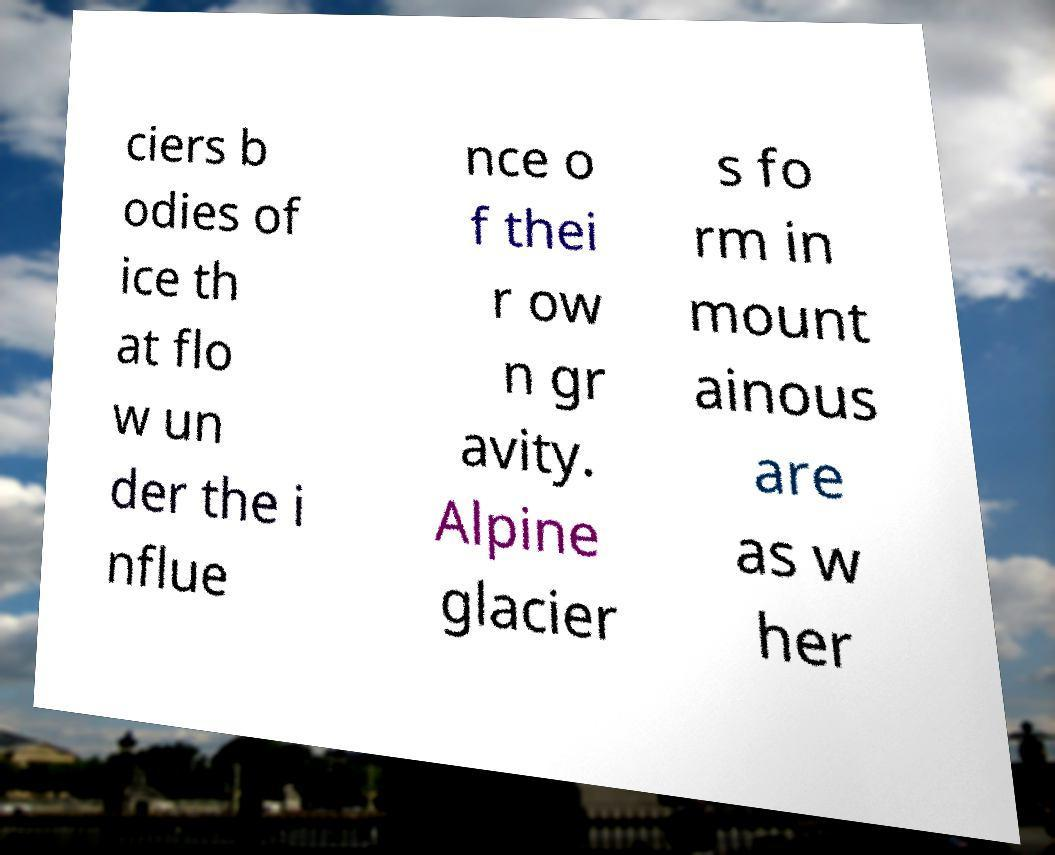For documentation purposes, I need the text within this image transcribed. Could you provide that? ciers b odies of ice th at flo w un der the i nflue nce o f thei r ow n gr avity. Alpine glacier s fo rm in mount ainous are as w her 